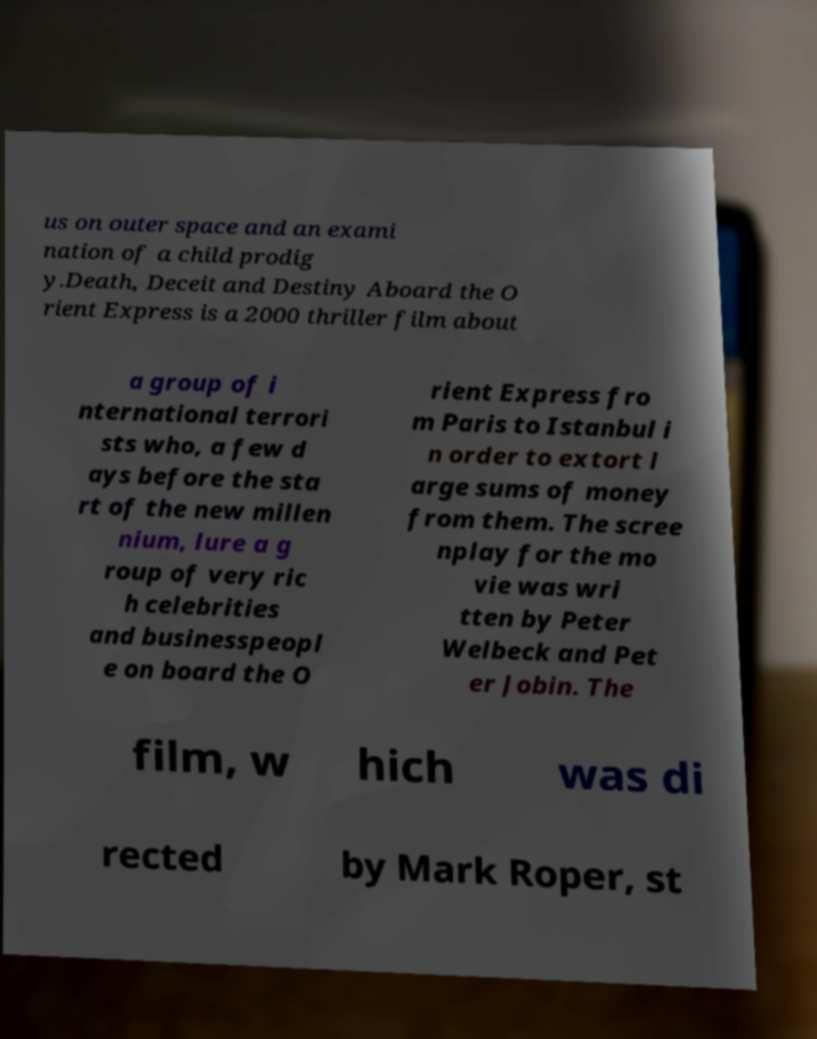What messages or text are displayed in this image? I need them in a readable, typed format. us on outer space and an exami nation of a child prodig y.Death, Deceit and Destiny Aboard the O rient Express is a 2000 thriller film about a group of i nternational terrori sts who, a few d ays before the sta rt of the new millen nium, lure a g roup of very ric h celebrities and businesspeopl e on board the O rient Express fro m Paris to Istanbul i n order to extort l arge sums of money from them. The scree nplay for the mo vie was wri tten by Peter Welbeck and Pet er Jobin. The film, w hich was di rected by Mark Roper, st 